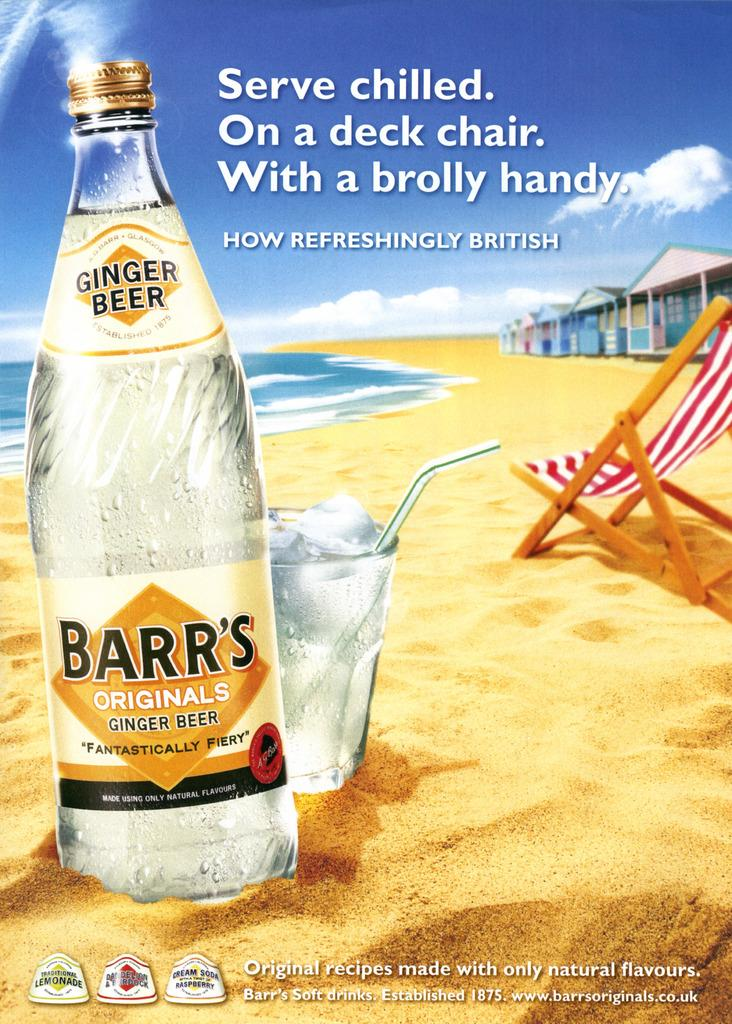Provide a one-sentence caption for the provided image. An advertisement displays a bottle for Barr's Originals Ginger Ale. 